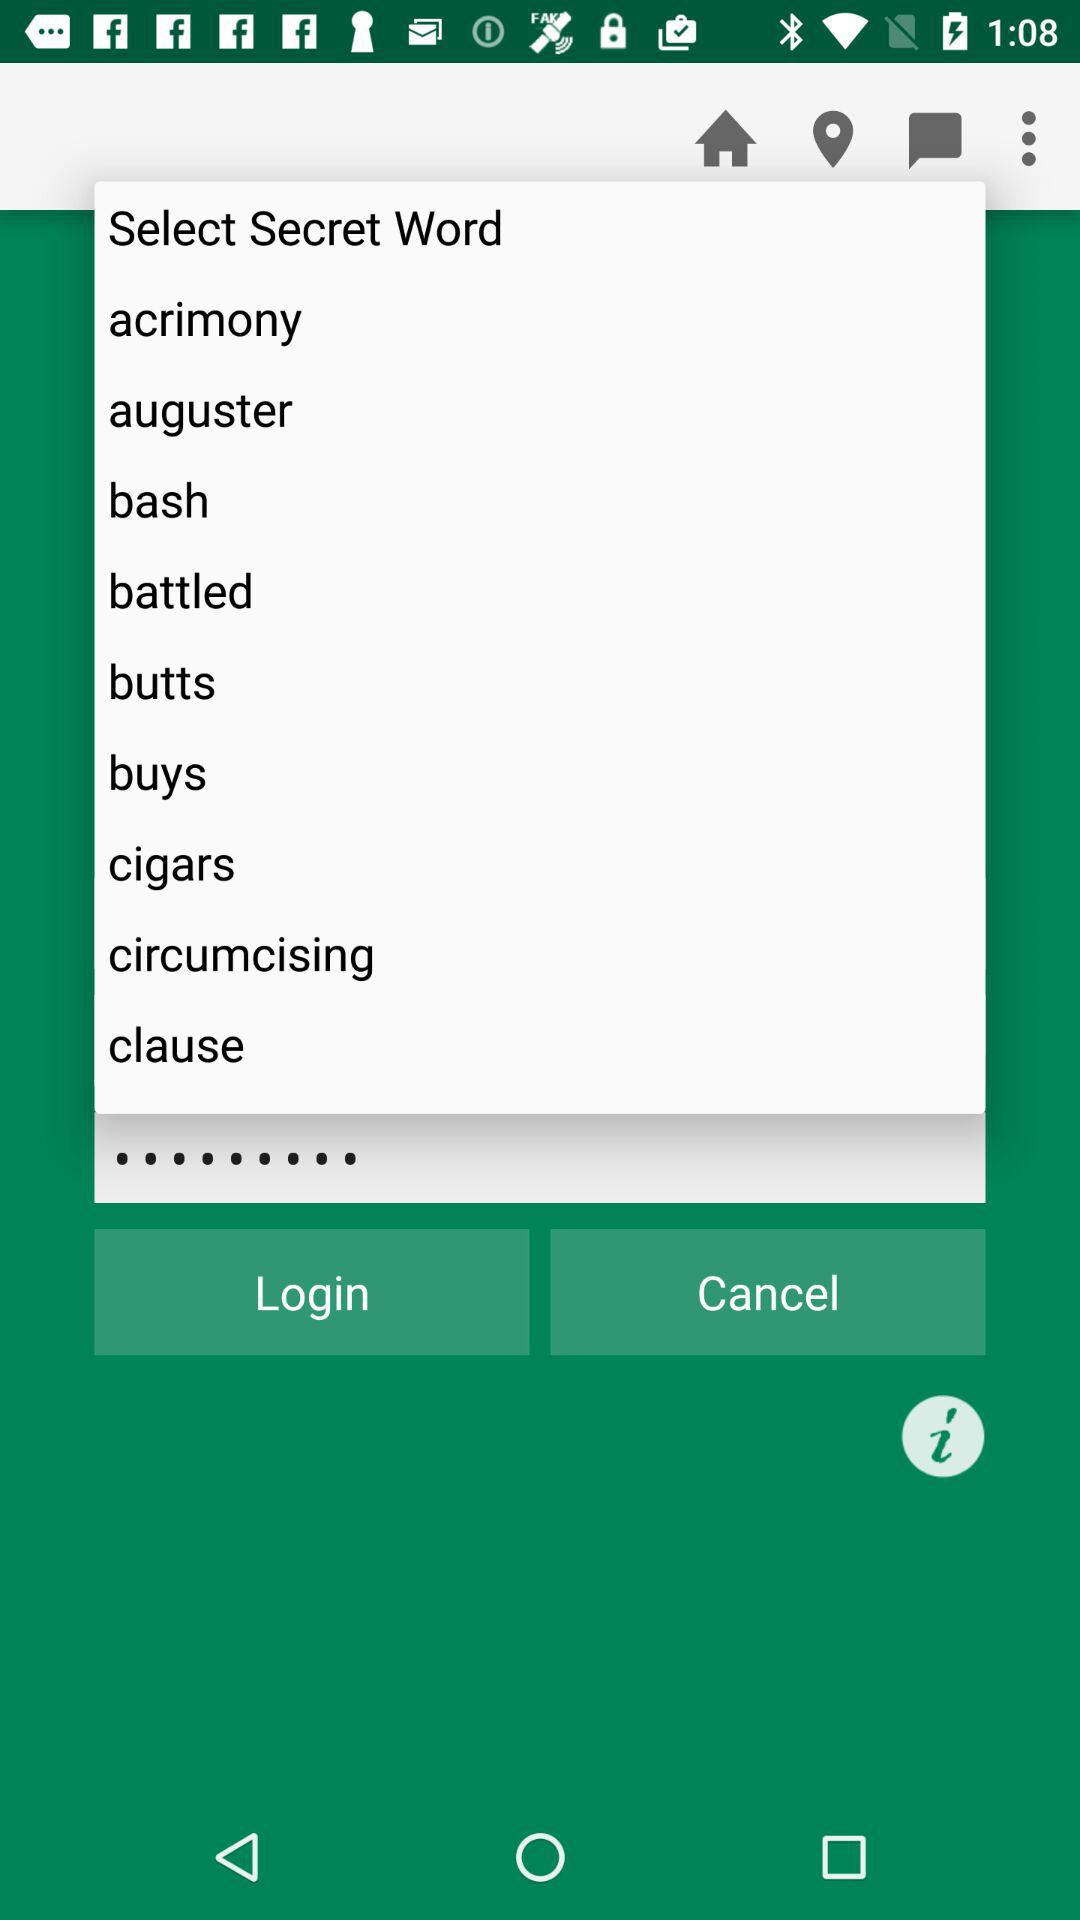What are the lists of "Secret Word"? The lists are "acrimony", "auguster", "bash", "battled", "butts", "buys", "cigars", "circumcising" and "clause". 